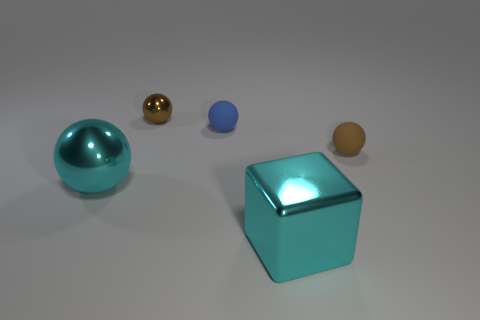Is the color of the tiny metallic object the same as the sphere on the right side of the blue matte sphere?
Offer a terse response. Yes. Is there a rubber sphere that is behind the rubber object in front of the matte object behind the brown matte sphere?
Give a very brief answer. Yes. There is a small brown object that is made of the same material as the big sphere; what is its shape?
Give a very brief answer. Sphere. What is the shape of the brown matte object?
Provide a short and direct response. Sphere. Does the tiny brown object behind the small blue sphere have the same shape as the small brown matte thing?
Your answer should be compact. Yes. Is the number of cyan objects that are in front of the cyan ball greater than the number of big metallic spheres that are behind the brown metallic sphere?
Your response must be concise. Yes. How many other objects are the same size as the blue matte ball?
Your response must be concise. 2. There is a brown metallic object; is its shape the same as the tiny brown matte thing behind the cyan metal block?
Ensure brevity in your answer.  Yes. What number of shiny objects are cubes or balls?
Your answer should be compact. 3. Are there any tiny matte balls that have the same color as the big sphere?
Make the answer very short. No. 